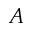Convert formula to latex. <formula><loc_0><loc_0><loc_500><loc_500>A</formula> 